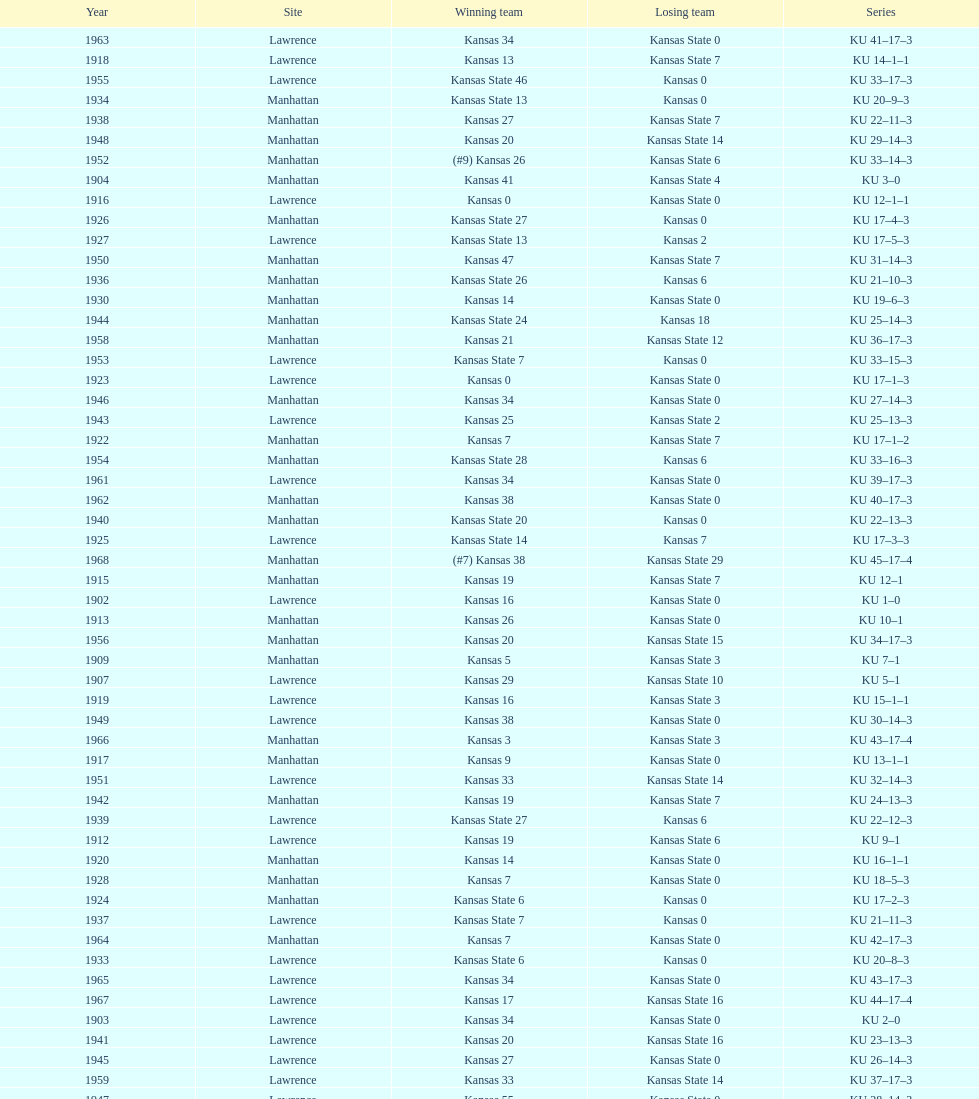How many times did kansas and kansas state play in lawrence from 1902-1968? 34. 